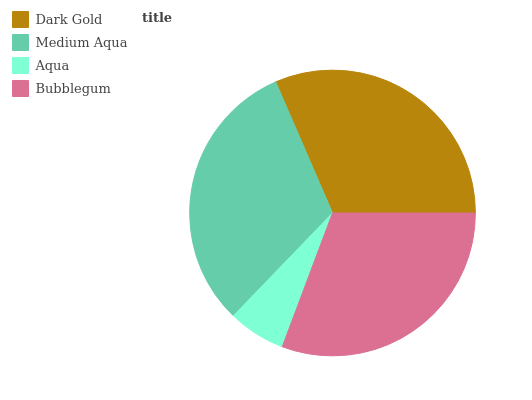Is Aqua the minimum?
Answer yes or no. Yes. Is Dark Gold the maximum?
Answer yes or no. Yes. Is Medium Aqua the minimum?
Answer yes or no. No. Is Medium Aqua the maximum?
Answer yes or no. No. Is Dark Gold greater than Medium Aqua?
Answer yes or no. Yes. Is Medium Aqua less than Dark Gold?
Answer yes or no. Yes. Is Medium Aqua greater than Dark Gold?
Answer yes or no. No. Is Dark Gold less than Medium Aqua?
Answer yes or no. No. Is Medium Aqua the high median?
Answer yes or no. Yes. Is Bubblegum the low median?
Answer yes or no. Yes. Is Aqua the high median?
Answer yes or no. No. Is Dark Gold the low median?
Answer yes or no. No. 